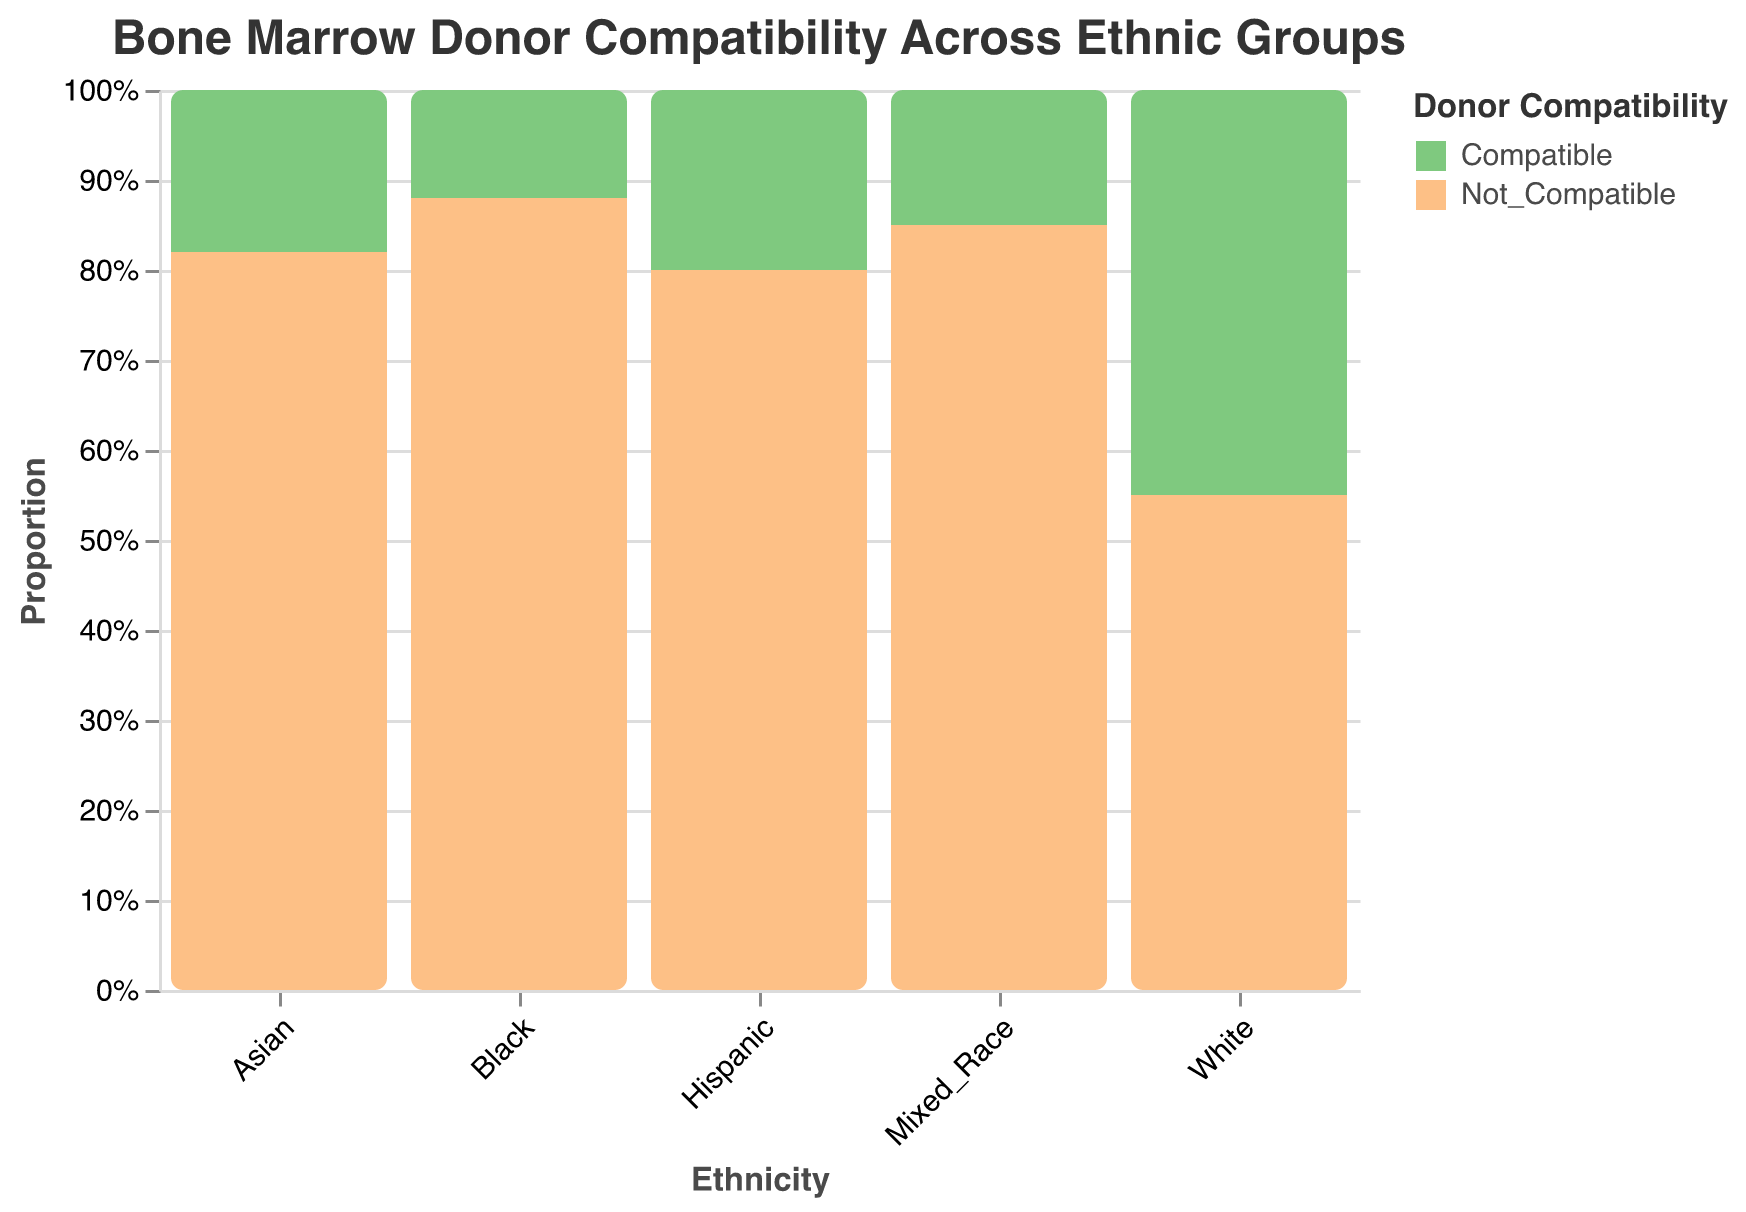What is the title of the figure? The title is located at the top of the figure and summarizes the content of the plot.
Answer: Bone Marrow Donor Compatibility Across Ethnic Groups Which ethnic group has the highest number of compatible donors? By looking at the size of the green (Compatible) sections for each ethnic group, the largest one is for the "White" category.
Answer: White Which ethnic group has the highest number of non-compatible donors? By looking at the size of the orange (Not_Compatible) sections for each ethnic group, the largest one is for the "Black" category.
Answer: Black What color represents compatible donors in the plot? The legend indicates the color coding for Donor Compatibility. Compatible donors are represented by the green color.
Answer: Green What proportion of White donors are not compatible? For the White ethnicity, the green (Compatible) area plus the orange (Not_Compatible) area sum up to a total of 100%. The orange section (Not_Compatible) represents 55%.
Answer: 55% How many ethnic groups are represented in the plot? The x-axis labels show the different ethnic groups presented in the figure. There are five such labels.
Answer: 5 Which group has a higher proportion of compatible donors, Hispanic or Asian? By comparing the green sections (Compatible) of the Hispanic and Asian ethnic groups, the Hispanic group has a larger proportion of compatible donors.
Answer: Hispanic What is the total number of compatible donors in the plot? By summing up the numbers of compatible donors for all ethnicities: 450 (White) + 120 (Black) + 200 (Hispanic) + 180 (Asian) + 150 (Mixed_Race) = 1100.
Answer: 1100 Which ethnic group has the closest proportions of compatible and non-compatible donors? The group where the green and orange sections are closest in size would be the Whites, 45% compatibility compared to 55% non-compatibility.
Answer: White 